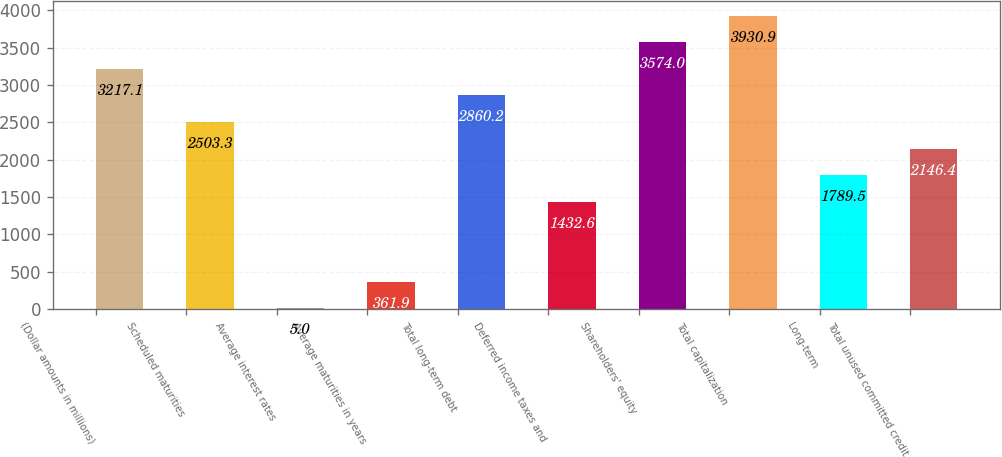Convert chart to OTSL. <chart><loc_0><loc_0><loc_500><loc_500><bar_chart><fcel>(Dollar amounts in millions)<fcel>Scheduled maturities<fcel>Average interest rates<fcel>Average maturities in years<fcel>Total long-term debt<fcel>Deferred income taxes and<fcel>Shareholders' equity<fcel>Total capitalization<fcel>Long-term<fcel>Total unused committed credit<nl><fcel>3217.1<fcel>2503.3<fcel>5<fcel>361.9<fcel>2860.2<fcel>1432.6<fcel>3574<fcel>3930.9<fcel>1789.5<fcel>2146.4<nl></chart> 